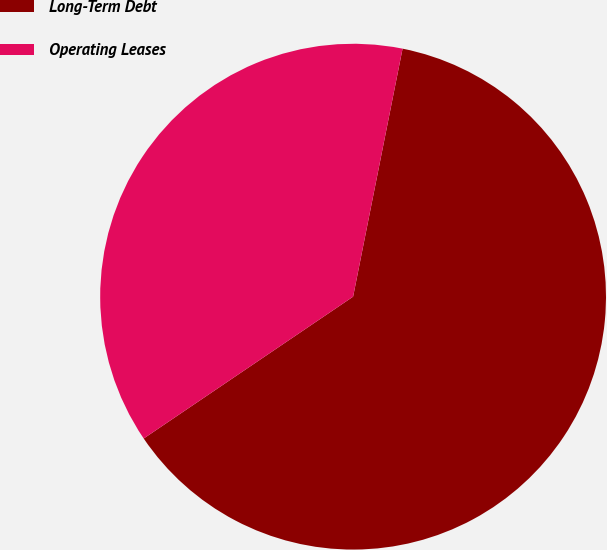Convert chart. <chart><loc_0><loc_0><loc_500><loc_500><pie_chart><fcel>Long-Term Debt<fcel>Operating Leases<nl><fcel>62.39%<fcel>37.61%<nl></chart> 